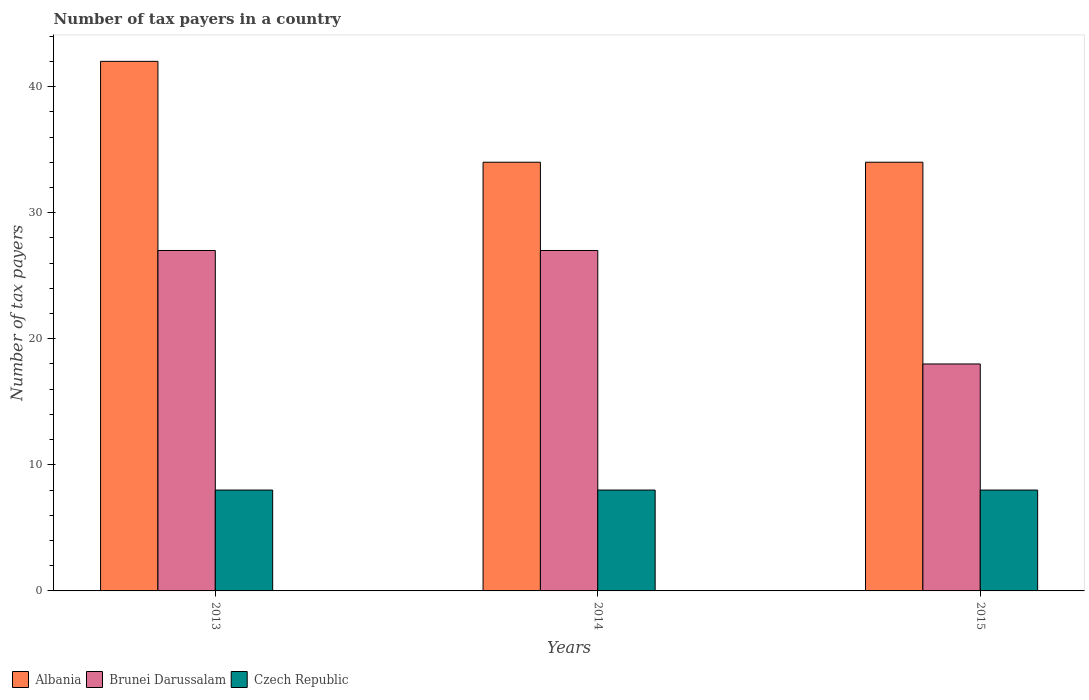How many different coloured bars are there?
Offer a terse response. 3. Are the number of bars per tick equal to the number of legend labels?
Ensure brevity in your answer.  Yes. How many bars are there on the 2nd tick from the left?
Your answer should be very brief. 3. How many bars are there on the 3rd tick from the right?
Offer a terse response. 3. What is the label of the 3rd group of bars from the left?
Keep it short and to the point. 2015. In how many cases, is the number of bars for a given year not equal to the number of legend labels?
Offer a very short reply. 0. What is the number of tax payers in in Czech Republic in 2013?
Your answer should be very brief. 8. Across all years, what is the maximum number of tax payers in in Albania?
Your answer should be very brief. 42. Across all years, what is the minimum number of tax payers in in Albania?
Offer a terse response. 34. In which year was the number of tax payers in in Albania maximum?
Offer a terse response. 2013. In which year was the number of tax payers in in Brunei Darussalam minimum?
Your answer should be very brief. 2015. What is the total number of tax payers in in Albania in the graph?
Provide a short and direct response. 110. In the year 2015, what is the difference between the number of tax payers in in Albania and number of tax payers in in Czech Republic?
Keep it short and to the point. 26. In how many years, is the number of tax payers in in Albania greater than 14?
Your response must be concise. 3. What is the ratio of the number of tax payers in in Albania in 2013 to that in 2014?
Your answer should be compact. 1.24. In how many years, is the number of tax payers in in Czech Republic greater than the average number of tax payers in in Czech Republic taken over all years?
Offer a very short reply. 0. Is the sum of the number of tax payers in in Brunei Darussalam in 2013 and 2014 greater than the maximum number of tax payers in in Albania across all years?
Ensure brevity in your answer.  Yes. What does the 1st bar from the left in 2013 represents?
Ensure brevity in your answer.  Albania. What does the 3rd bar from the right in 2014 represents?
Offer a very short reply. Albania. How many bars are there?
Provide a short and direct response. 9. What is the difference between two consecutive major ticks on the Y-axis?
Provide a short and direct response. 10. Are the values on the major ticks of Y-axis written in scientific E-notation?
Your response must be concise. No. Does the graph contain any zero values?
Provide a succinct answer. No. Does the graph contain grids?
Your answer should be very brief. No. How many legend labels are there?
Give a very brief answer. 3. What is the title of the graph?
Keep it short and to the point. Number of tax payers in a country. Does "Panama" appear as one of the legend labels in the graph?
Offer a terse response. No. What is the label or title of the Y-axis?
Offer a very short reply. Number of tax payers. What is the Number of tax payers of Albania in 2013?
Offer a very short reply. 42. What is the Number of tax payers in Brunei Darussalam in 2013?
Ensure brevity in your answer.  27. What is the Number of tax payers of Czech Republic in 2013?
Provide a succinct answer. 8. What is the Number of tax payers of Brunei Darussalam in 2014?
Make the answer very short. 27. What is the Number of tax payers in Czech Republic in 2014?
Provide a succinct answer. 8. Across all years, what is the maximum Number of tax payers of Brunei Darussalam?
Provide a short and direct response. 27. Across all years, what is the minimum Number of tax payers of Albania?
Ensure brevity in your answer.  34. Across all years, what is the minimum Number of tax payers in Brunei Darussalam?
Provide a succinct answer. 18. What is the total Number of tax payers of Albania in the graph?
Provide a succinct answer. 110. What is the total Number of tax payers of Brunei Darussalam in the graph?
Your answer should be very brief. 72. What is the difference between the Number of tax payers of Brunei Darussalam in 2013 and that in 2014?
Provide a succinct answer. 0. What is the difference between the Number of tax payers in Brunei Darussalam in 2014 and that in 2015?
Give a very brief answer. 9. What is the difference between the Number of tax payers of Brunei Darussalam in 2013 and the Number of tax payers of Czech Republic in 2014?
Your response must be concise. 19. What is the difference between the Number of tax payers of Albania in 2013 and the Number of tax payers of Czech Republic in 2015?
Provide a succinct answer. 34. What is the difference between the Number of tax payers in Albania in 2014 and the Number of tax payers in Brunei Darussalam in 2015?
Offer a very short reply. 16. What is the average Number of tax payers in Albania per year?
Ensure brevity in your answer.  36.67. What is the average Number of tax payers in Brunei Darussalam per year?
Keep it short and to the point. 24. What is the average Number of tax payers in Czech Republic per year?
Keep it short and to the point. 8. In the year 2013, what is the difference between the Number of tax payers in Albania and Number of tax payers in Brunei Darussalam?
Provide a short and direct response. 15. In the year 2014, what is the difference between the Number of tax payers in Albania and Number of tax payers in Czech Republic?
Provide a short and direct response. 26. In the year 2014, what is the difference between the Number of tax payers in Brunei Darussalam and Number of tax payers in Czech Republic?
Your answer should be very brief. 19. In the year 2015, what is the difference between the Number of tax payers of Brunei Darussalam and Number of tax payers of Czech Republic?
Your answer should be compact. 10. What is the ratio of the Number of tax payers of Albania in 2013 to that in 2014?
Provide a succinct answer. 1.24. What is the ratio of the Number of tax payers in Czech Republic in 2013 to that in 2014?
Your answer should be very brief. 1. What is the ratio of the Number of tax payers in Albania in 2013 to that in 2015?
Ensure brevity in your answer.  1.24. What is the ratio of the Number of tax payers of Czech Republic in 2013 to that in 2015?
Offer a terse response. 1. What is the ratio of the Number of tax payers in Albania in 2014 to that in 2015?
Provide a succinct answer. 1. What is the ratio of the Number of tax payers in Brunei Darussalam in 2014 to that in 2015?
Provide a short and direct response. 1.5. What is the difference between the highest and the second highest Number of tax payers of Albania?
Your answer should be very brief. 8. 